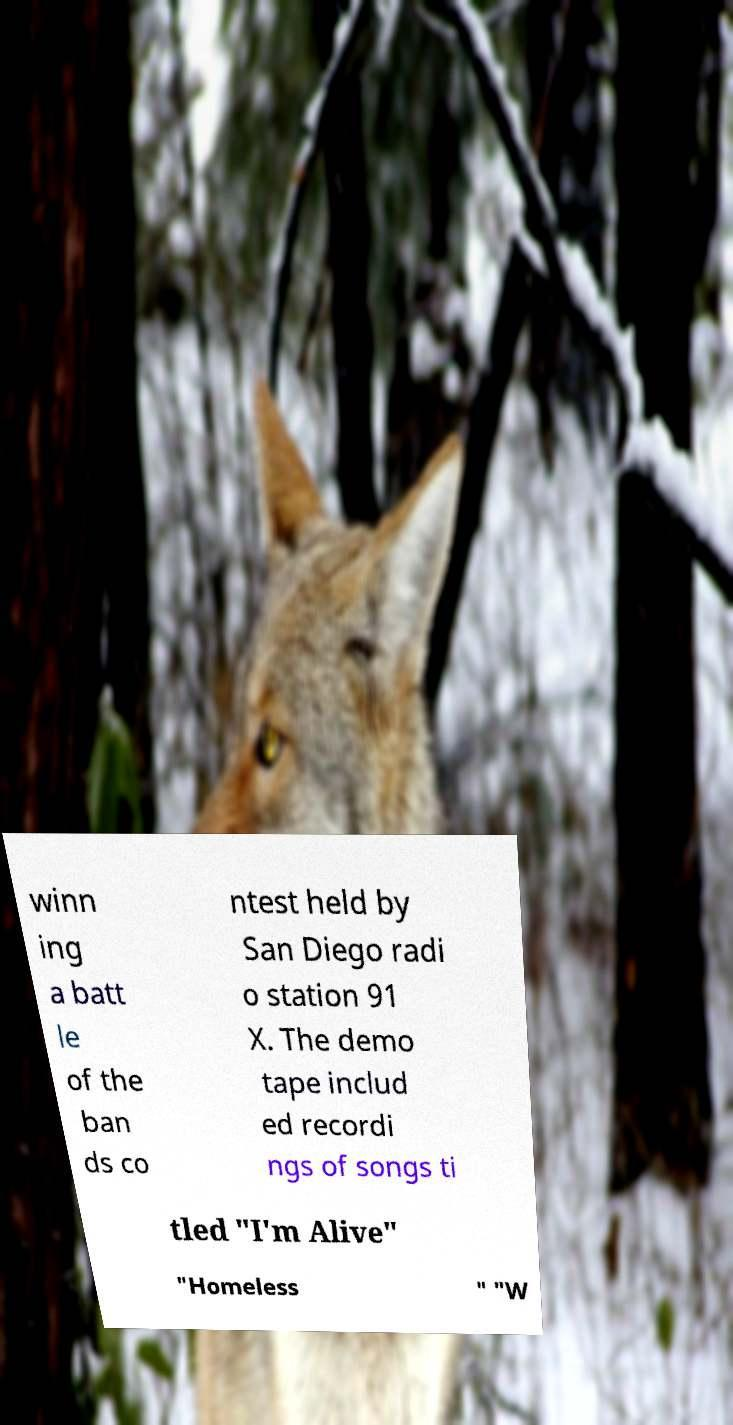I need the written content from this picture converted into text. Can you do that? winn ing a batt le of the ban ds co ntest held by San Diego radi o station 91 X. The demo tape includ ed recordi ngs of songs ti tled "I'm Alive" "Homeless " "W 